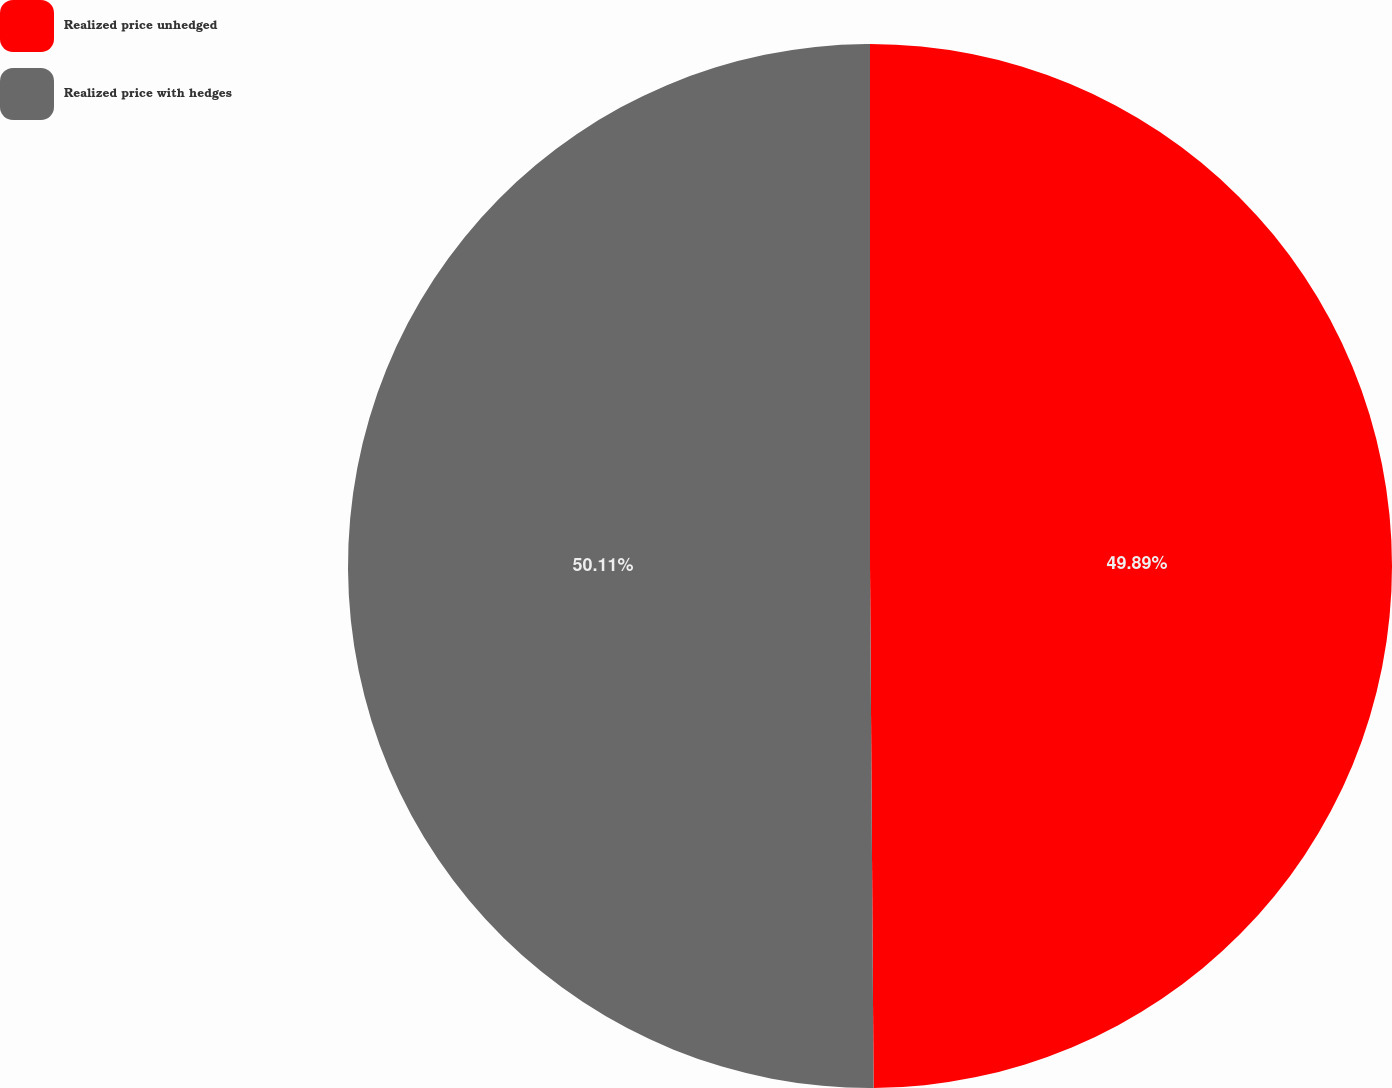Convert chart to OTSL. <chart><loc_0><loc_0><loc_500><loc_500><pie_chart><fcel>Realized price unhedged<fcel>Realized price with hedges<nl><fcel>49.89%<fcel>50.11%<nl></chart> 